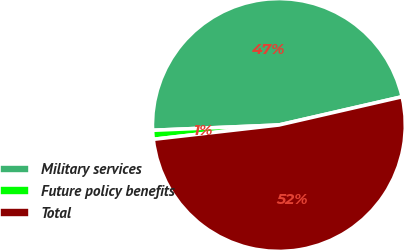Convert chart to OTSL. <chart><loc_0><loc_0><loc_500><loc_500><pie_chart><fcel>Military services<fcel>Future policy benefits<fcel>Total<nl><fcel>47.08%<fcel>1.14%<fcel>51.78%<nl></chart> 